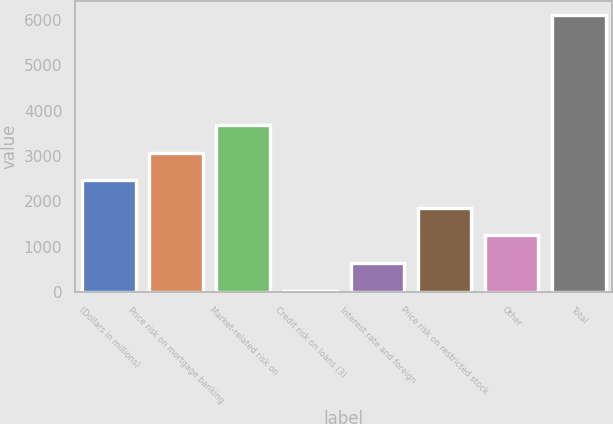Convert chart. <chart><loc_0><loc_0><loc_500><loc_500><bar_chart><fcel>(Dollars in millions)<fcel>Price risk on mortgage banking<fcel>Market-related risk on<fcel>Credit risk on loans (3)<fcel>Interest rate and foreign<fcel>Price risk on restricted stock<fcel>Other<fcel>Total<nl><fcel>2464.8<fcel>3073.5<fcel>3682.2<fcel>30<fcel>638.7<fcel>1856.1<fcel>1247.4<fcel>6117<nl></chart> 